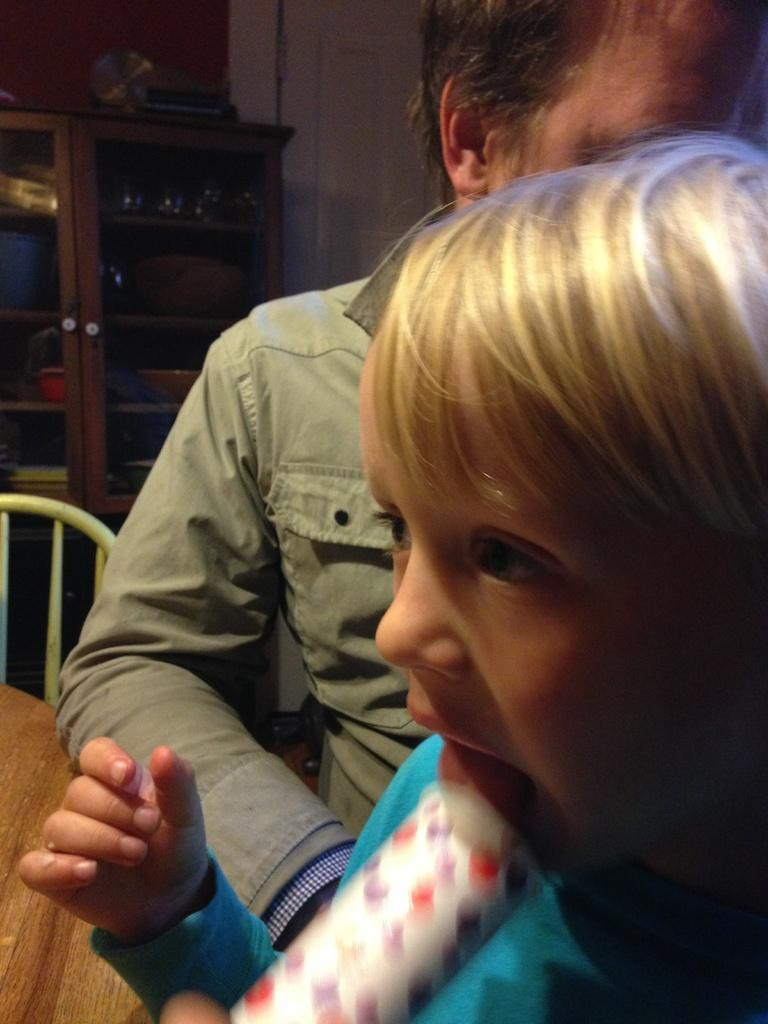Who is present in the image? There is a man and a child in the image. What furniture can be seen in the image? There is a chair and a table in the image. What is the purpose of the cupboard in the image? The cupboard has objects in it, suggesting it is used for storage. What is visible in the background of the image? There is a wall in the background of the image. What is the rate of lumber production in the image? There is no mention of lumber production or any related activities in the image. 